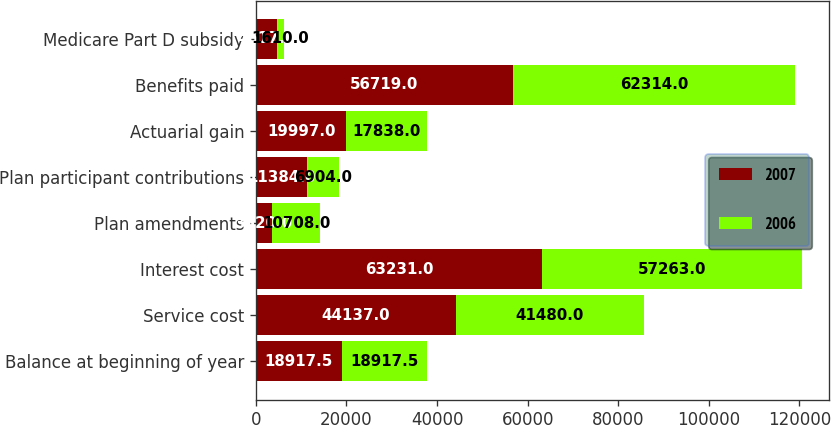<chart> <loc_0><loc_0><loc_500><loc_500><stacked_bar_chart><ecel><fcel>Balance at beginning of year<fcel>Service cost<fcel>Interest cost<fcel>Plan amendments<fcel>Plan participant contributions<fcel>Actuarial gain<fcel>Benefits paid<fcel>Medicare Part D subsidy<nl><fcel>2007<fcel>18917.5<fcel>44137<fcel>63231<fcel>3520<fcel>11384<fcel>19997<fcel>56719<fcel>4617<nl><fcel>2006<fcel>18917.5<fcel>41480<fcel>57263<fcel>10708<fcel>6904<fcel>17838<fcel>62314<fcel>1610<nl></chart> 